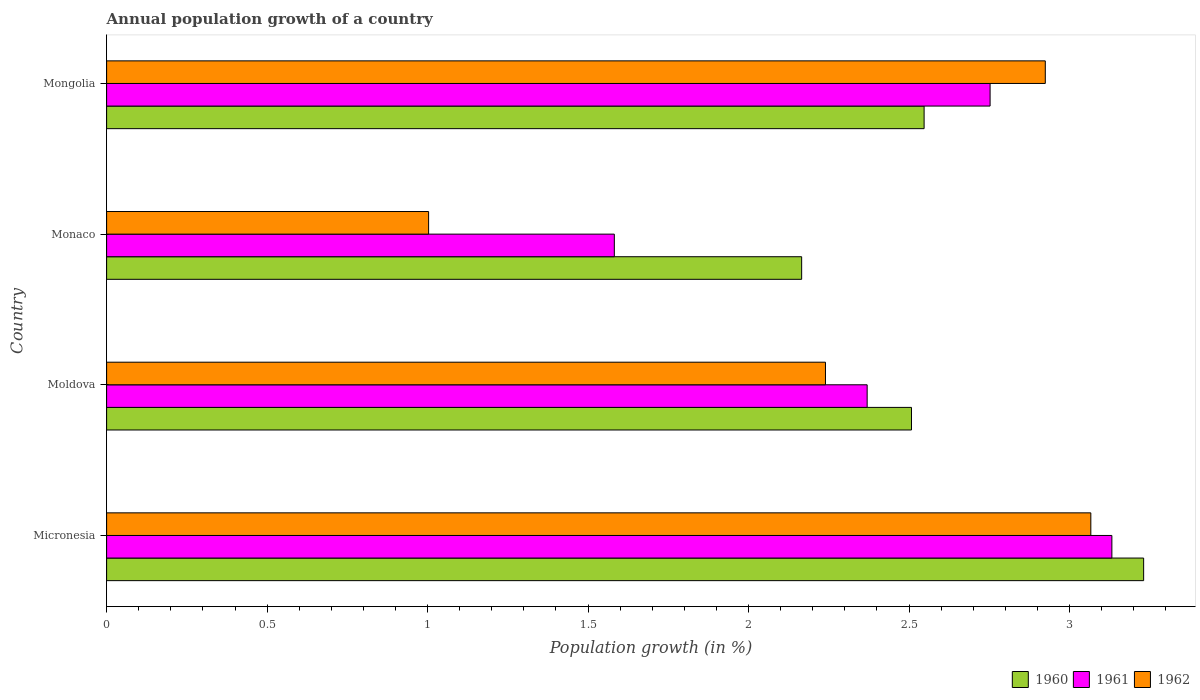How many different coloured bars are there?
Your response must be concise. 3. How many groups of bars are there?
Your response must be concise. 4. Are the number of bars per tick equal to the number of legend labels?
Your response must be concise. Yes. What is the label of the 3rd group of bars from the top?
Your answer should be very brief. Moldova. What is the annual population growth in 1960 in Micronesia?
Provide a short and direct response. 3.23. Across all countries, what is the maximum annual population growth in 1960?
Give a very brief answer. 3.23. Across all countries, what is the minimum annual population growth in 1962?
Ensure brevity in your answer.  1. In which country was the annual population growth in 1961 maximum?
Provide a short and direct response. Micronesia. In which country was the annual population growth in 1961 minimum?
Keep it short and to the point. Monaco. What is the total annual population growth in 1962 in the graph?
Your answer should be very brief. 9.23. What is the difference between the annual population growth in 1962 in Micronesia and that in Mongolia?
Ensure brevity in your answer.  0.14. What is the difference between the annual population growth in 1961 in Moldova and the annual population growth in 1962 in Micronesia?
Your response must be concise. -0.7. What is the average annual population growth in 1961 per country?
Ensure brevity in your answer.  2.46. What is the difference between the annual population growth in 1961 and annual population growth in 1960 in Mongolia?
Keep it short and to the point. 0.21. In how many countries, is the annual population growth in 1960 greater than 2.3 %?
Your answer should be very brief. 3. What is the ratio of the annual population growth in 1961 in Moldova to that in Monaco?
Provide a succinct answer. 1.5. Is the difference between the annual population growth in 1961 in Micronesia and Mongolia greater than the difference between the annual population growth in 1960 in Micronesia and Mongolia?
Your answer should be very brief. No. What is the difference between the highest and the second highest annual population growth in 1961?
Make the answer very short. 0.38. What is the difference between the highest and the lowest annual population growth in 1961?
Offer a terse response. 1.55. What does the 3rd bar from the top in Monaco represents?
Your response must be concise. 1960. What does the 2nd bar from the bottom in Mongolia represents?
Provide a succinct answer. 1961. Is it the case that in every country, the sum of the annual population growth in 1962 and annual population growth in 1960 is greater than the annual population growth in 1961?
Keep it short and to the point. Yes. How many countries are there in the graph?
Keep it short and to the point. 4. What is the difference between two consecutive major ticks on the X-axis?
Offer a terse response. 0.5. Are the values on the major ticks of X-axis written in scientific E-notation?
Provide a succinct answer. No. What is the title of the graph?
Offer a terse response. Annual population growth of a country. What is the label or title of the X-axis?
Your response must be concise. Population growth (in %). What is the label or title of the Y-axis?
Make the answer very short. Country. What is the Population growth (in %) of 1960 in Micronesia?
Your response must be concise. 3.23. What is the Population growth (in %) of 1961 in Micronesia?
Ensure brevity in your answer.  3.13. What is the Population growth (in %) of 1962 in Micronesia?
Make the answer very short. 3.07. What is the Population growth (in %) in 1960 in Moldova?
Ensure brevity in your answer.  2.51. What is the Population growth (in %) in 1961 in Moldova?
Your answer should be compact. 2.37. What is the Population growth (in %) of 1962 in Moldova?
Offer a terse response. 2.24. What is the Population growth (in %) of 1960 in Monaco?
Give a very brief answer. 2.17. What is the Population growth (in %) of 1961 in Monaco?
Offer a very short reply. 1.58. What is the Population growth (in %) of 1962 in Monaco?
Make the answer very short. 1. What is the Population growth (in %) in 1960 in Mongolia?
Offer a very short reply. 2.55. What is the Population growth (in %) of 1961 in Mongolia?
Your response must be concise. 2.75. What is the Population growth (in %) of 1962 in Mongolia?
Provide a succinct answer. 2.92. Across all countries, what is the maximum Population growth (in %) of 1960?
Keep it short and to the point. 3.23. Across all countries, what is the maximum Population growth (in %) of 1961?
Keep it short and to the point. 3.13. Across all countries, what is the maximum Population growth (in %) of 1962?
Provide a succinct answer. 3.07. Across all countries, what is the minimum Population growth (in %) in 1960?
Provide a succinct answer. 2.17. Across all countries, what is the minimum Population growth (in %) of 1961?
Make the answer very short. 1.58. Across all countries, what is the minimum Population growth (in %) of 1962?
Your response must be concise. 1. What is the total Population growth (in %) in 1960 in the graph?
Provide a short and direct response. 10.45. What is the total Population growth (in %) of 1961 in the graph?
Ensure brevity in your answer.  9.84. What is the total Population growth (in %) in 1962 in the graph?
Your answer should be compact. 9.23. What is the difference between the Population growth (in %) in 1960 in Micronesia and that in Moldova?
Make the answer very short. 0.72. What is the difference between the Population growth (in %) of 1961 in Micronesia and that in Moldova?
Ensure brevity in your answer.  0.76. What is the difference between the Population growth (in %) of 1962 in Micronesia and that in Moldova?
Provide a succinct answer. 0.83. What is the difference between the Population growth (in %) in 1960 in Micronesia and that in Monaco?
Provide a short and direct response. 1.07. What is the difference between the Population growth (in %) in 1961 in Micronesia and that in Monaco?
Provide a succinct answer. 1.55. What is the difference between the Population growth (in %) in 1962 in Micronesia and that in Monaco?
Offer a very short reply. 2.06. What is the difference between the Population growth (in %) of 1960 in Micronesia and that in Mongolia?
Ensure brevity in your answer.  0.68. What is the difference between the Population growth (in %) in 1961 in Micronesia and that in Mongolia?
Your answer should be very brief. 0.38. What is the difference between the Population growth (in %) in 1962 in Micronesia and that in Mongolia?
Provide a succinct answer. 0.14. What is the difference between the Population growth (in %) in 1960 in Moldova and that in Monaco?
Provide a succinct answer. 0.34. What is the difference between the Population growth (in %) in 1961 in Moldova and that in Monaco?
Keep it short and to the point. 0.79. What is the difference between the Population growth (in %) in 1962 in Moldova and that in Monaco?
Give a very brief answer. 1.24. What is the difference between the Population growth (in %) of 1960 in Moldova and that in Mongolia?
Make the answer very short. -0.04. What is the difference between the Population growth (in %) of 1961 in Moldova and that in Mongolia?
Keep it short and to the point. -0.38. What is the difference between the Population growth (in %) in 1962 in Moldova and that in Mongolia?
Offer a very short reply. -0.68. What is the difference between the Population growth (in %) of 1960 in Monaco and that in Mongolia?
Your answer should be compact. -0.38. What is the difference between the Population growth (in %) in 1961 in Monaco and that in Mongolia?
Make the answer very short. -1.17. What is the difference between the Population growth (in %) of 1962 in Monaco and that in Mongolia?
Provide a succinct answer. -1.92. What is the difference between the Population growth (in %) of 1960 in Micronesia and the Population growth (in %) of 1961 in Moldova?
Give a very brief answer. 0.86. What is the difference between the Population growth (in %) in 1961 in Micronesia and the Population growth (in %) in 1962 in Moldova?
Provide a succinct answer. 0.89. What is the difference between the Population growth (in %) in 1960 in Micronesia and the Population growth (in %) in 1961 in Monaco?
Offer a very short reply. 1.65. What is the difference between the Population growth (in %) in 1960 in Micronesia and the Population growth (in %) in 1962 in Monaco?
Your answer should be very brief. 2.23. What is the difference between the Population growth (in %) of 1961 in Micronesia and the Population growth (in %) of 1962 in Monaco?
Your response must be concise. 2.13. What is the difference between the Population growth (in %) in 1960 in Micronesia and the Population growth (in %) in 1961 in Mongolia?
Your answer should be compact. 0.48. What is the difference between the Population growth (in %) in 1960 in Micronesia and the Population growth (in %) in 1962 in Mongolia?
Provide a short and direct response. 0.31. What is the difference between the Population growth (in %) in 1961 in Micronesia and the Population growth (in %) in 1962 in Mongolia?
Provide a short and direct response. 0.21. What is the difference between the Population growth (in %) in 1960 in Moldova and the Population growth (in %) in 1961 in Monaco?
Offer a terse response. 0.93. What is the difference between the Population growth (in %) in 1960 in Moldova and the Population growth (in %) in 1962 in Monaco?
Keep it short and to the point. 1.5. What is the difference between the Population growth (in %) in 1961 in Moldova and the Population growth (in %) in 1962 in Monaco?
Offer a terse response. 1.37. What is the difference between the Population growth (in %) of 1960 in Moldova and the Population growth (in %) of 1961 in Mongolia?
Provide a short and direct response. -0.24. What is the difference between the Population growth (in %) in 1960 in Moldova and the Population growth (in %) in 1962 in Mongolia?
Your response must be concise. -0.42. What is the difference between the Population growth (in %) in 1961 in Moldova and the Population growth (in %) in 1962 in Mongolia?
Provide a succinct answer. -0.56. What is the difference between the Population growth (in %) of 1960 in Monaco and the Population growth (in %) of 1961 in Mongolia?
Give a very brief answer. -0.59. What is the difference between the Population growth (in %) in 1960 in Monaco and the Population growth (in %) in 1962 in Mongolia?
Give a very brief answer. -0.76. What is the difference between the Population growth (in %) of 1961 in Monaco and the Population growth (in %) of 1962 in Mongolia?
Your answer should be compact. -1.34. What is the average Population growth (in %) in 1960 per country?
Keep it short and to the point. 2.61. What is the average Population growth (in %) in 1961 per country?
Keep it short and to the point. 2.46. What is the average Population growth (in %) of 1962 per country?
Keep it short and to the point. 2.31. What is the difference between the Population growth (in %) of 1960 and Population growth (in %) of 1961 in Micronesia?
Your answer should be very brief. 0.1. What is the difference between the Population growth (in %) of 1960 and Population growth (in %) of 1962 in Micronesia?
Your response must be concise. 0.16. What is the difference between the Population growth (in %) in 1961 and Population growth (in %) in 1962 in Micronesia?
Offer a terse response. 0.07. What is the difference between the Population growth (in %) in 1960 and Population growth (in %) in 1961 in Moldova?
Your response must be concise. 0.14. What is the difference between the Population growth (in %) of 1960 and Population growth (in %) of 1962 in Moldova?
Give a very brief answer. 0.27. What is the difference between the Population growth (in %) in 1961 and Population growth (in %) in 1962 in Moldova?
Ensure brevity in your answer.  0.13. What is the difference between the Population growth (in %) in 1960 and Population growth (in %) in 1961 in Monaco?
Provide a short and direct response. 0.58. What is the difference between the Population growth (in %) in 1960 and Population growth (in %) in 1962 in Monaco?
Your answer should be compact. 1.16. What is the difference between the Population growth (in %) in 1961 and Population growth (in %) in 1962 in Monaco?
Provide a short and direct response. 0.58. What is the difference between the Population growth (in %) in 1960 and Population growth (in %) in 1961 in Mongolia?
Provide a short and direct response. -0.21. What is the difference between the Population growth (in %) of 1960 and Population growth (in %) of 1962 in Mongolia?
Your answer should be very brief. -0.38. What is the difference between the Population growth (in %) in 1961 and Population growth (in %) in 1962 in Mongolia?
Your answer should be compact. -0.17. What is the ratio of the Population growth (in %) in 1960 in Micronesia to that in Moldova?
Offer a terse response. 1.29. What is the ratio of the Population growth (in %) of 1961 in Micronesia to that in Moldova?
Offer a terse response. 1.32. What is the ratio of the Population growth (in %) of 1962 in Micronesia to that in Moldova?
Provide a succinct answer. 1.37. What is the ratio of the Population growth (in %) in 1960 in Micronesia to that in Monaco?
Provide a succinct answer. 1.49. What is the ratio of the Population growth (in %) of 1961 in Micronesia to that in Monaco?
Your response must be concise. 1.98. What is the ratio of the Population growth (in %) in 1962 in Micronesia to that in Monaco?
Your answer should be compact. 3.06. What is the ratio of the Population growth (in %) in 1960 in Micronesia to that in Mongolia?
Make the answer very short. 1.27. What is the ratio of the Population growth (in %) in 1961 in Micronesia to that in Mongolia?
Offer a terse response. 1.14. What is the ratio of the Population growth (in %) of 1962 in Micronesia to that in Mongolia?
Your response must be concise. 1.05. What is the ratio of the Population growth (in %) in 1960 in Moldova to that in Monaco?
Your response must be concise. 1.16. What is the ratio of the Population growth (in %) of 1961 in Moldova to that in Monaco?
Give a very brief answer. 1.5. What is the ratio of the Population growth (in %) in 1962 in Moldova to that in Monaco?
Your answer should be compact. 2.23. What is the ratio of the Population growth (in %) in 1960 in Moldova to that in Mongolia?
Keep it short and to the point. 0.98. What is the ratio of the Population growth (in %) in 1961 in Moldova to that in Mongolia?
Your response must be concise. 0.86. What is the ratio of the Population growth (in %) of 1962 in Moldova to that in Mongolia?
Make the answer very short. 0.77. What is the ratio of the Population growth (in %) in 1960 in Monaco to that in Mongolia?
Keep it short and to the point. 0.85. What is the ratio of the Population growth (in %) in 1961 in Monaco to that in Mongolia?
Keep it short and to the point. 0.57. What is the ratio of the Population growth (in %) in 1962 in Monaco to that in Mongolia?
Make the answer very short. 0.34. What is the difference between the highest and the second highest Population growth (in %) in 1960?
Keep it short and to the point. 0.68. What is the difference between the highest and the second highest Population growth (in %) of 1961?
Offer a very short reply. 0.38. What is the difference between the highest and the second highest Population growth (in %) of 1962?
Give a very brief answer. 0.14. What is the difference between the highest and the lowest Population growth (in %) in 1960?
Your response must be concise. 1.07. What is the difference between the highest and the lowest Population growth (in %) in 1961?
Your response must be concise. 1.55. What is the difference between the highest and the lowest Population growth (in %) of 1962?
Your answer should be compact. 2.06. 